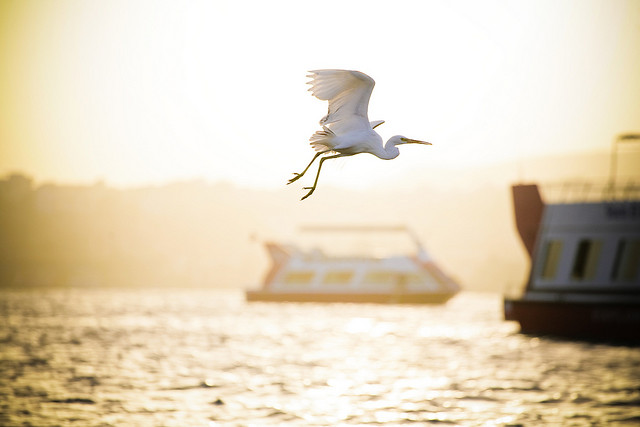Envision a grand narrative or story that this image could be a part of. The bird, an ageless guardian of the river, has watched over the waters for centuries. Legend has it that this majestic creature holds the soul of a great explorer who once navigated these very waters in search of a mythical treasure. The boats in the image, seemingly ordinary, belong to a group of explorers who unknowingly tread the sharegpt4v/same path. As the sun sets, the bird watches them closely, a silent protector and a guiding spirit, ensuring that they avoid the perils of the river. Unbeknownst to them, their journey is not just one of discovery but of destiny, intertwined with the lore and legends of this mystical waterway. 